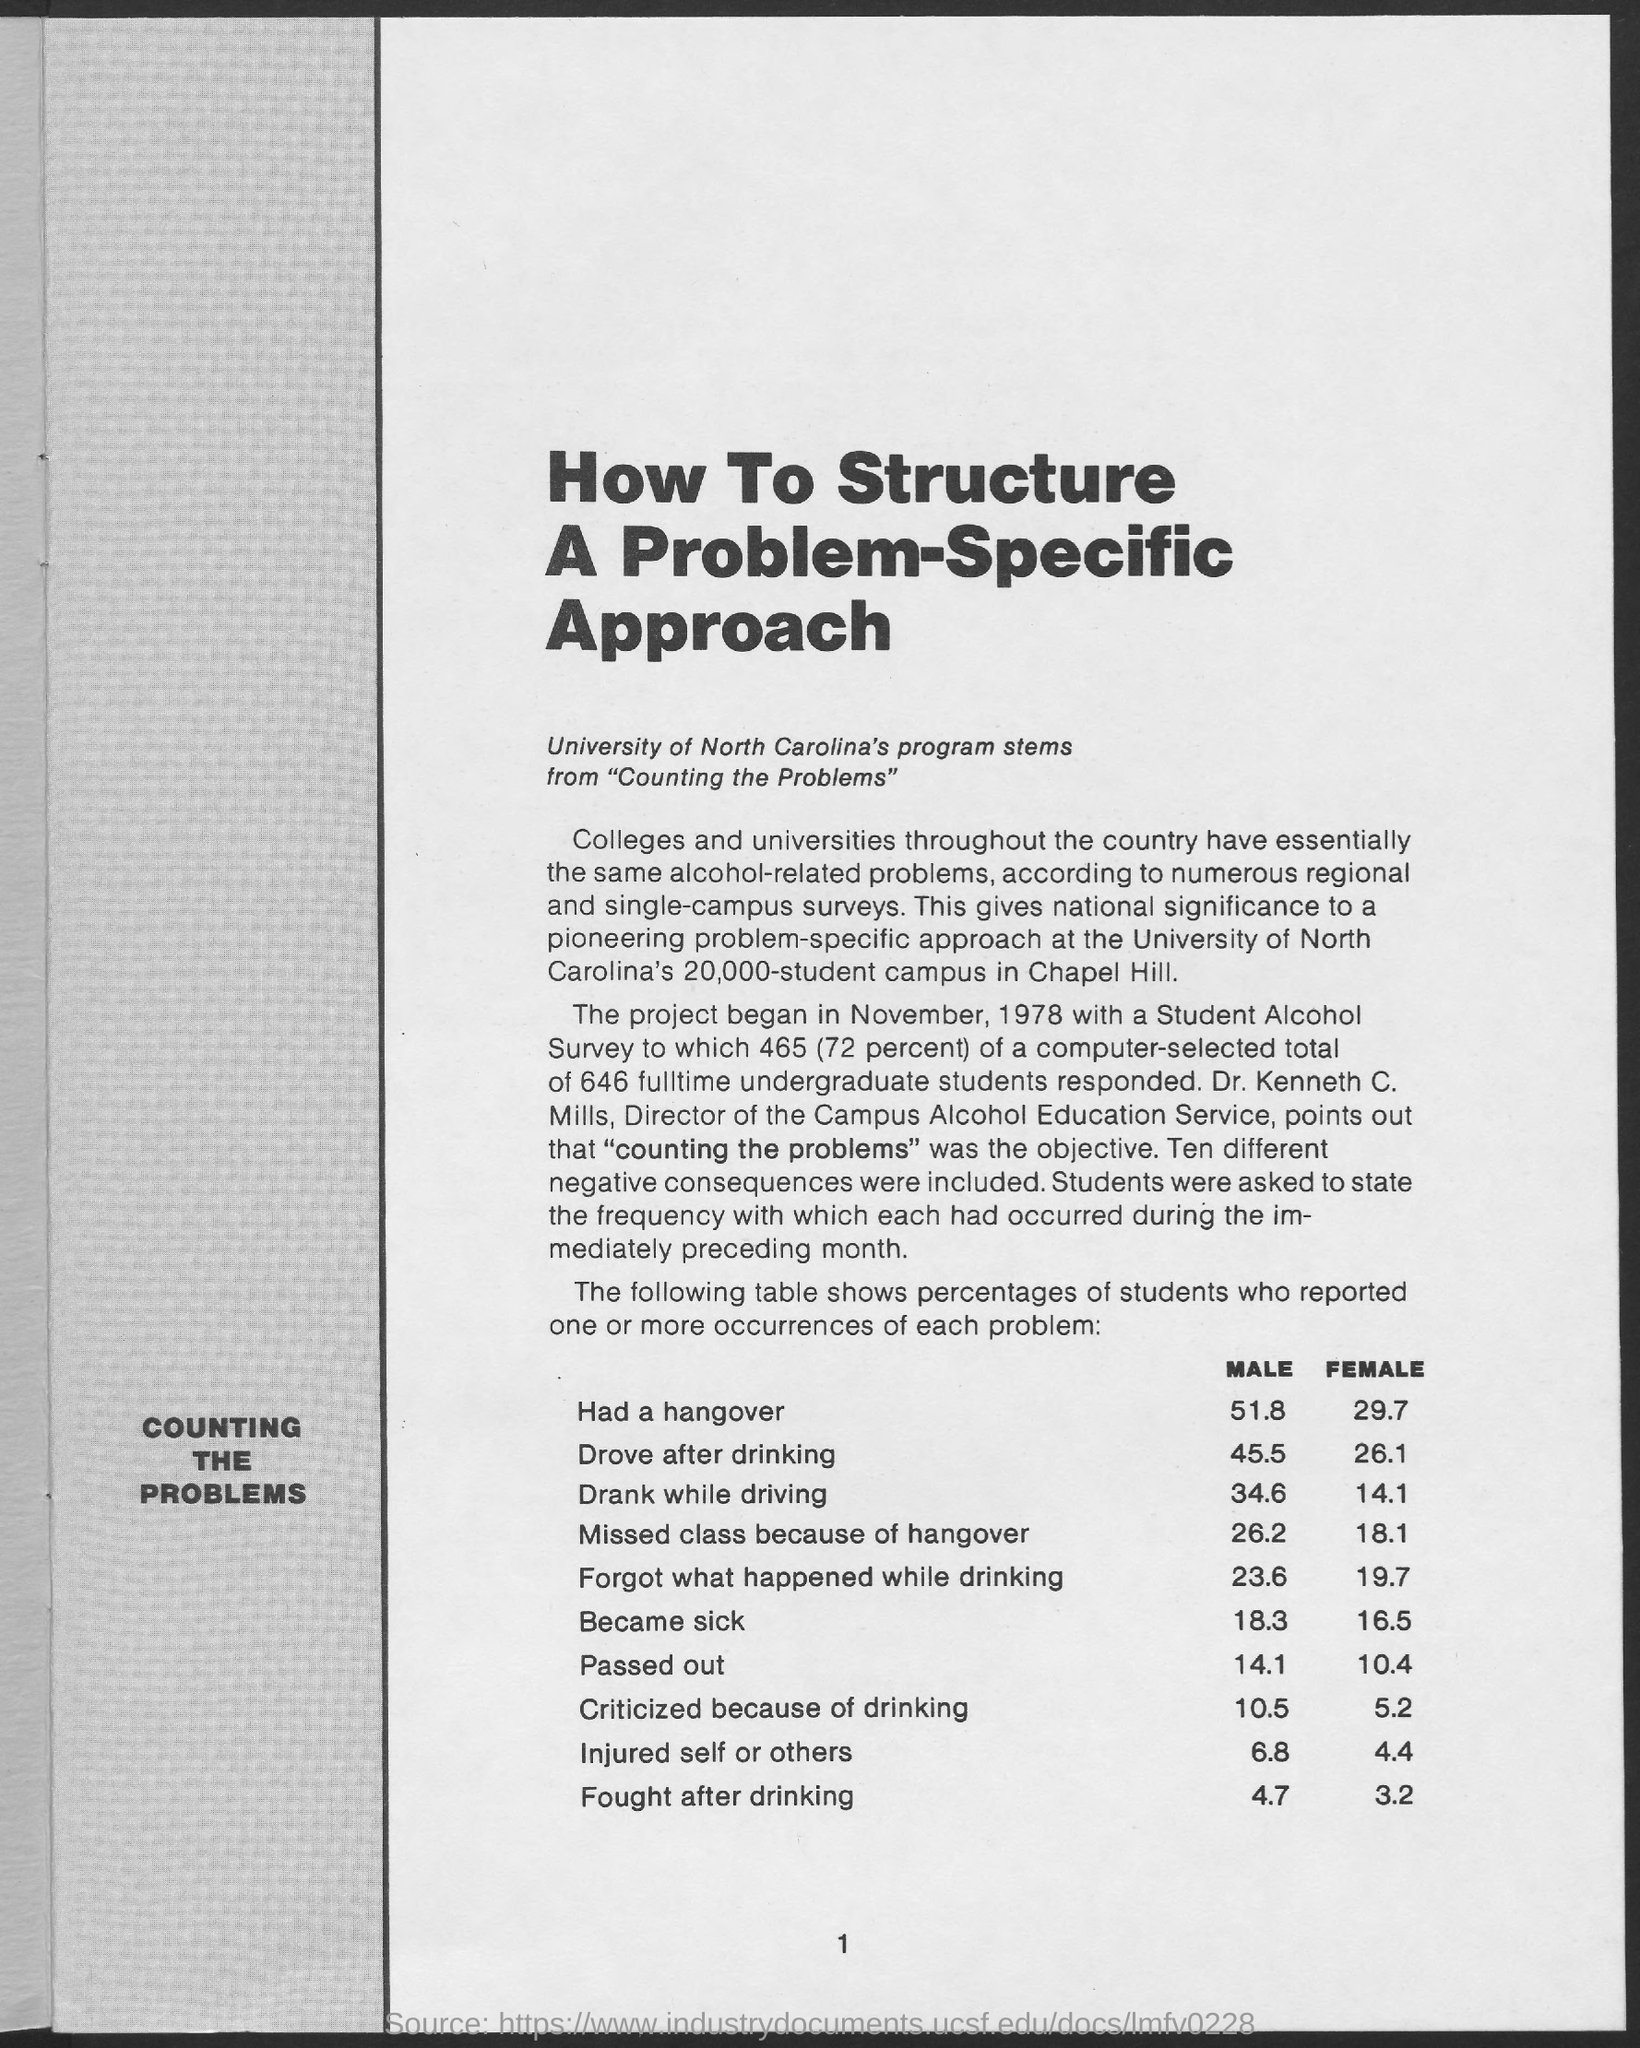What is the page no mentioned in this document?
Give a very brief answer. 1. What is the percentage of male students who drove after drinking?
Keep it short and to the point. 45.5. What is the percentage of female students who drank while driving?
Your answer should be very brief. 14.1. What percentage of male students injured self or others?
Provide a succinct answer. 6.8. What percentage of female students fought after drinking as per the table given?
Provide a short and direct response. 3.2. Who is the Director of the Campus Alcohol Education Service?
Your response must be concise. Dr. Kenneth C. Mills. What is the main heading of the document?
Make the answer very short. How To Structure A Problem-Specific Approach. 